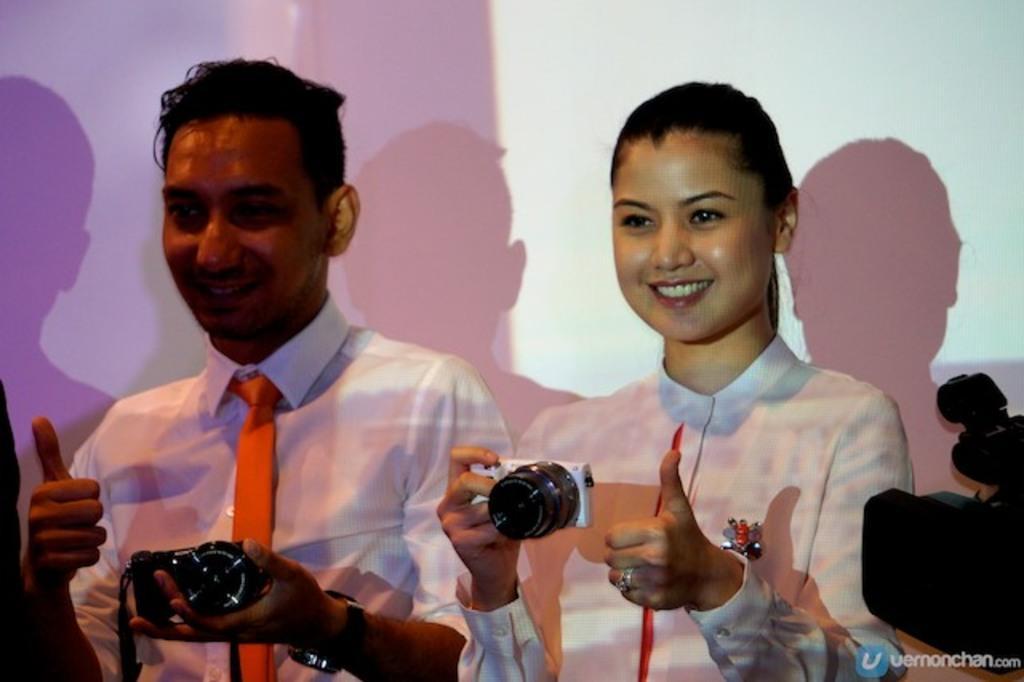Describe this image in one or two sentences. On the right there is a camera. On the right there is a woman she wear a white dress she is holding a camera she is smiling ,her hair is short. On the left there is a man he wear white shirt and tie ,he is holding a camera ,he is smiling. 